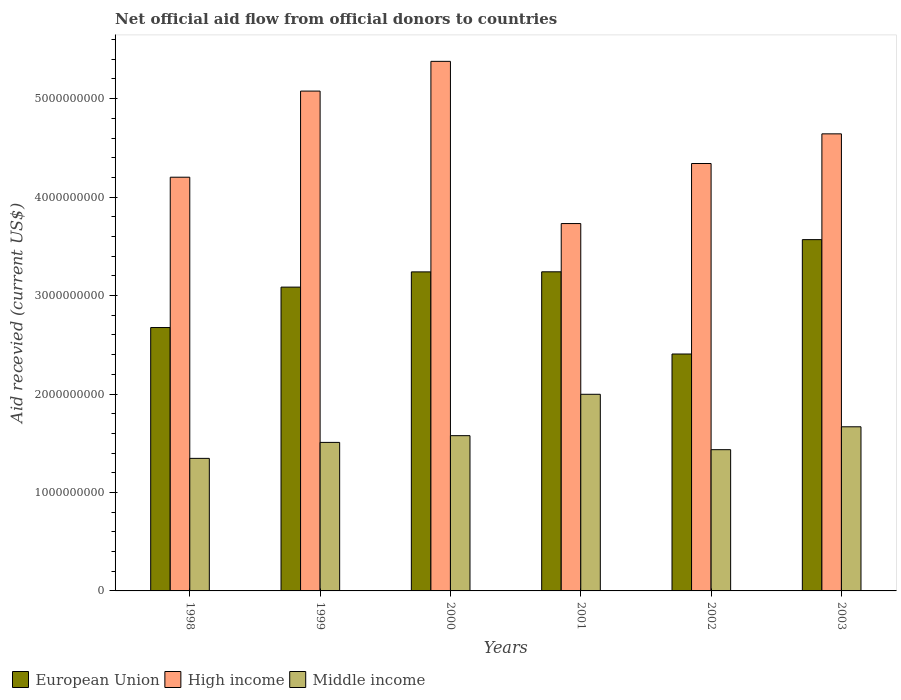How many different coloured bars are there?
Ensure brevity in your answer.  3. Are the number of bars on each tick of the X-axis equal?
Ensure brevity in your answer.  Yes. How many bars are there on the 3rd tick from the right?
Offer a very short reply. 3. What is the label of the 5th group of bars from the left?
Offer a terse response. 2002. In how many cases, is the number of bars for a given year not equal to the number of legend labels?
Provide a short and direct response. 0. What is the total aid received in Middle income in 2000?
Make the answer very short. 1.58e+09. Across all years, what is the maximum total aid received in European Union?
Provide a short and direct response. 3.57e+09. Across all years, what is the minimum total aid received in High income?
Make the answer very short. 3.73e+09. In which year was the total aid received in Middle income maximum?
Your response must be concise. 2001. In which year was the total aid received in European Union minimum?
Your answer should be very brief. 2002. What is the total total aid received in European Union in the graph?
Give a very brief answer. 1.82e+1. What is the difference between the total aid received in Middle income in 2001 and that in 2003?
Keep it short and to the point. 3.30e+08. What is the difference between the total aid received in European Union in 2000 and the total aid received in High income in 2001?
Provide a succinct answer. -4.91e+08. What is the average total aid received in European Union per year?
Ensure brevity in your answer.  3.04e+09. In the year 2000, what is the difference between the total aid received in European Union and total aid received in High income?
Provide a succinct answer. -2.14e+09. What is the ratio of the total aid received in High income in 2000 to that in 2002?
Make the answer very short. 1.24. What is the difference between the highest and the second highest total aid received in Middle income?
Keep it short and to the point. 3.30e+08. What is the difference between the highest and the lowest total aid received in Middle income?
Your answer should be very brief. 6.51e+08. In how many years, is the total aid received in European Union greater than the average total aid received in European Union taken over all years?
Keep it short and to the point. 4. Is the sum of the total aid received in High income in 1999 and 2003 greater than the maximum total aid received in Middle income across all years?
Your response must be concise. Yes. What does the 2nd bar from the right in 1999 represents?
Make the answer very short. High income. Is it the case that in every year, the sum of the total aid received in European Union and total aid received in High income is greater than the total aid received in Middle income?
Ensure brevity in your answer.  Yes. How many bars are there?
Give a very brief answer. 18. Does the graph contain any zero values?
Offer a very short reply. No. Does the graph contain grids?
Provide a succinct answer. No. How many legend labels are there?
Provide a short and direct response. 3. How are the legend labels stacked?
Offer a very short reply. Horizontal. What is the title of the graph?
Provide a short and direct response. Net official aid flow from official donors to countries. Does "Caribbean small states" appear as one of the legend labels in the graph?
Your response must be concise. No. What is the label or title of the Y-axis?
Give a very brief answer. Aid recevied (current US$). What is the Aid recevied (current US$) of European Union in 1998?
Give a very brief answer. 2.68e+09. What is the Aid recevied (current US$) in High income in 1998?
Ensure brevity in your answer.  4.20e+09. What is the Aid recevied (current US$) of Middle income in 1998?
Offer a very short reply. 1.35e+09. What is the Aid recevied (current US$) in European Union in 1999?
Make the answer very short. 3.09e+09. What is the Aid recevied (current US$) in High income in 1999?
Offer a very short reply. 5.08e+09. What is the Aid recevied (current US$) in Middle income in 1999?
Make the answer very short. 1.51e+09. What is the Aid recevied (current US$) in European Union in 2000?
Your response must be concise. 3.24e+09. What is the Aid recevied (current US$) of High income in 2000?
Give a very brief answer. 5.38e+09. What is the Aid recevied (current US$) in Middle income in 2000?
Offer a terse response. 1.58e+09. What is the Aid recevied (current US$) of European Union in 2001?
Your answer should be very brief. 3.24e+09. What is the Aid recevied (current US$) in High income in 2001?
Keep it short and to the point. 3.73e+09. What is the Aid recevied (current US$) in Middle income in 2001?
Provide a short and direct response. 2.00e+09. What is the Aid recevied (current US$) in European Union in 2002?
Offer a terse response. 2.41e+09. What is the Aid recevied (current US$) in High income in 2002?
Offer a terse response. 4.34e+09. What is the Aid recevied (current US$) in Middle income in 2002?
Your answer should be very brief. 1.43e+09. What is the Aid recevied (current US$) in European Union in 2003?
Offer a very short reply. 3.57e+09. What is the Aid recevied (current US$) in High income in 2003?
Keep it short and to the point. 4.64e+09. What is the Aid recevied (current US$) of Middle income in 2003?
Provide a short and direct response. 1.67e+09. Across all years, what is the maximum Aid recevied (current US$) in European Union?
Make the answer very short. 3.57e+09. Across all years, what is the maximum Aid recevied (current US$) of High income?
Provide a succinct answer. 5.38e+09. Across all years, what is the maximum Aid recevied (current US$) of Middle income?
Give a very brief answer. 2.00e+09. Across all years, what is the minimum Aid recevied (current US$) in European Union?
Provide a short and direct response. 2.41e+09. Across all years, what is the minimum Aid recevied (current US$) of High income?
Your answer should be very brief. 3.73e+09. Across all years, what is the minimum Aid recevied (current US$) in Middle income?
Give a very brief answer. 1.35e+09. What is the total Aid recevied (current US$) in European Union in the graph?
Keep it short and to the point. 1.82e+1. What is the total Aid recevied (current US$) in High income in the graph?
Ensure brevity in your answer.  2.74e+1. What is the total Aid recevied (current US$) of Middle income in the graph?
Give a very brief answer. 9.53e+09. What is the difference between the Aid recevied (current US$) of European Union in 1998 and that in 1999?
Offer a terse response. -4.11e+08. What is the difference between the Aid recevied (current US$) of High income in 1998 and that in 1999?
Ensure brevity in your answer.  -8.75e+08. What is the difference between the Aid recevied (current US$) of Middle income in 1998 and that in 1999?
Provide a succinct answer. -1.62e+08. What is the difference between the Aid recevied (current US$) in European Union in 1998 and that in 2000?
Offer a very short reply. -5.65e+08. What is the difference between the Aid recevied (current US$) in High income in 1998 and that in 2000?
Provide a succinct answer. -1.18e+09. What is the difference between the Aid recevied (current US$) of Middle income in 1998 and that in 2000?
Keep it short and to the point. -2.31e+08. What is the difference between the Aid recevied (current US$) of European Union in 1998 and that in 2001?
Keep it short and to the point. -5.66e+08. What is the difference between the Aid recevied (current US$) of High income in 1998 and that in 2001?
Your answer should be compact. 4.71e+08. What is the difference between the Aid recevied (current US$) in Middle income in 1998 and that in 2001?
Give a very brief answer. -6.51e+08. What is the difference between the Aid recevied (current US$) of European Union in 1998 and that in 2002?
Your answer should be compact. 2.69e+08. What is the difference between the Aid recevied (current US$) in High income in 1998 and that in 2002?
Offer a terse response. -1.39e+08. What is the difference between the Aid recevied (current US$) of Middle income in 1998 and that in 2002?
Offer a terse response. -8.82e+07. What is the difference between the Aid recevied (current US$) in European Union in 1998 and that in 2003?
Ensure brevity in your answer.  -8.93e+08. What is the difference between the Aid recevied (current US$) in High income in 1998 and that in 2003?
Keep it short and to the point. -4.40e+08. What is the difference between the Aid recevied (current US$) of Middle income in 1998 and that in 2003?
Your answer should be compact. -3.21e+08. What is the difference between the Aid recevied (current US$) in European Union in 1999 and that in 2000?
Your answer should be very brief. -1.55e+08. What is the difference between the Aid recevied (current US$) of High income in 1999 and that in 2000?
Give a very brief answer. -3.02e+08. What is the difference between the Aid recevied (current US$) in Middle income in 1999 and that in 2000?
Offer a terse response. -6.85e+07. What is the difference between the Aid recevied (current US$) of European Union in 1999 and that in 2001?
Keep it short and to the point. -1.55e+08. What is the difference between the Aid recevied (current US$) of High income in 1999 and that in 2001?
Your answer should be very brief. 1.35e+09. What is the difference between the Aid recevied (current US$) of Middle income in 1999 and that in 2001?
Your answer should be very brief. -4.89e+08. What is the difference between the Aid recevied (current US$) of European Union in 1999 and that in 2002?
Provide a short and direct response. 6.79e+08. What is the difference between the Aid recevied (current US$) of High income in 1999 and that in 2002?
Provide a short and direct response. 7.36e+08. What is the difference between the Aid recevied (current US$) in Middle income in 1999 and that in 2002?
Your response must be concise. 7.39e+07. What is the difference between the Aid recevied (current US$) in European Union in 1999 and that in 2003?
Offer a terse response. -4.82e+08. What is the difference between the Aid recevied (current US$) in High income in 1999 and that in 2003?
Your response must be concise. 4.34e+08. What is the difference between the Aid recevied (current US$) of Middle income in 1999 and that in 2003?
Your answer should be compact. -1.59e+08. What is the difference between the Aid recevied (current US$) in European Union in 2000 and that in 2001?
Offer a very short reply. -7.70e+05. What is the difference between the Aid recevied (current US$) of High income in 2000 and that in 2001?
Give a very brief answer. 1.65e+09. What is the difference between the Aid recevied (current US$) in Middle income in 2000 and that in 2001?
Ensure brevity in your answer.  -4.20e+08. What is the difference between the Aid recevied (current US$) in European Union in 2000 and that in 2002?
Ensure brevity in your answer.  8.34e+08. What is the difference between the Aid recevied (current US$) in High income in 2000 and that in 2002?
Offer a very short reply. 1.04e+09. What is the difference between the Aid recevied (current US$) of Middle income in 2000 and that in 2002?
Ensure brevity in your answer.  1.42e+08. What is the difference between the Aid recevied (current US$) in European Union in 2000 and that in 2003?
Your answer should be compact. -3.28e+08. What is the difference between the Aid recevied (current US$) in High income in 2000 and that in 2003?
Offer a terse response. 7.36e+08. What is the difference between the Aid recevied (current US$) in Middle income in 2000 and that in 2003?
Your response must be concise. -9.02e+07. What is the difference between the Aid recevied (current US$) of European Union in 2001 and that in 2002?
Keep it short and to the point. 8.35e+08. What is the difference between the Aid recevied (current US$) of High income in 2001 and that in 2002?
Provide a short and direct response. -6.10e+08. What is the difference between the Aid recevied (current US$) in Middle income in 2001 and that in 2002?
Give a very brief answer. 5.63e+08. What is the difference between the Aid recevied (current US$) of European Union in 2001 and that in 2003?
Keep it short and to the point. -3.27e+08. What is the difference between the Aid recevied (current US$) in High income in 2001 and that in 2003?
Your answer should be very brief. -9.11e+08. What is the difference between the Aid recevied (current US$) of Middle income in 2001 and that in 2003?
Your answer should be very brief. 3.30e+08. What is the difference between the Aid recevied (current US$) of European Union in 2002 and that in 2003?
Your response must be concise. -1.16e+09. What is the difference between the Aid recevied (current US$) of High income in 2002 and that in 2003?
Make the answer very short. -3.01e+08. What is the difference between the Aid recevied (current US$) of Middle income in 2002 and that in 2003?
Provide a short and direct response. -2.33e+08. What is the difference between the Aid recevied (current US$) of European Union in 1998 and the Aid recevied (current US$) of High income in 1999?
Your answer should be compact. -2.40e+09. What is the difference between the Aid recevied (current US$) of European Union in 1998 and the Aid recevied (current US$) of Middle income in 1999?
Give a very brief answer. 1.17e+09. What is the difference between the Aid recevied (current US$) of High income in 1998 and the Aid recevied (current US$) of Middle income in 1999?
Your answer should be compact. 2.69e+09. What is the difference between the Aid recevied (current US$) of European Union in 1998 and the Aid recevied (current US$) of High income in 2000?
Ensure brevity in your answer.  -2.70e+09. What is the difference between the Aid recevied (current US$) of European Union in 1998 and the Aid recevied (current US$) of Middle income in 2000?
Your answer should be compact. 1.10e+09. What is the difference between the Aid recevied (current US$) of High income in 1998 and the Aid recevied (current US$) of Middle income in 2000?
Give a very brief answer. 2.63e+09. What is the difference between the Aid recevied (current US$) of European Union in 1998 and the Aid recevied (current US$) of High income in 2001?
Offer a terse response. -1.06e+09. What is the difference between the Aid recevied (current US$) in European Union in 1998 and the Aid recevied (current US$) in Middle income in 2001?
Give a very brief answer. 6.78e+08. What is the difference between the Aid recevied (current US$) in High income in 1998 and the Aid recevied (current US$) in Middle income in 2001?
Offer a terse response. 2.20e+09. What is the difference between the Aid recevied (current US$) in European Union in 1998 and the Aid recevied (current US$) in High income in 2002?
Offer a very short reply. -1.67e+09. What is the difference between the Aid recevied (current US$) in European Union in 1998 and the Aid recevied (current US$) in Middle income in 2002?
Your response must be concise. 1.24e+09. What is the difference between the Aid recevied (current US$) of High income in 1998 and the Aid recevied (current US$) of Middle income in 2002?
Keep it short and to the point. 2.77e+09. What is the difference between the Aid recevied (current US$) of European Union in 1998 and the Aid recevied (current US$) of High income in 2003?
Your response must be concise. -1.97e+09. What is the difference between the Aid recevied (current US$) in European Union in 1998 and the Aid recevied (current US$) in Middle income in 2003?
Provide a succinct answer. 1.01e+09. What is the difference between the Aid recevied (current US$) of High income in 1998 and the Aid recevied (current US$) of Middle income in 2003?
Your answer should be compact. 2.53e+09. What is the difference between the Aid recevied (current US$) in European Union in 1999 and the Aid recevied (current US$) in High income in 2000?
Your answer should be very brief. -2.29e+09. What is the difference between the Aid recevied (current US$) in European Union in 1999 and the Aid recevied (current US$) in Middle income in 2000?
Offer a terse response. 1.51e+09. What is the difference between the Aid recevied (current US$) of High income in 1999 and the Aid recevied (current US$) of Middle income in 2000?
Your response must be concise. 3.50e+09. What is the difference between the Aid recevied (current US$) in European Union in 1999 and the Aid recevied (current US$) in High income in 2001?
Provide a short and direct response. -6.46e+08. What is the difference between the Aid recevied (current US$) in European Union in 1999 and the Aid recevied (current US$) in Middle income in 2001?
Ensure brevity in your answer.  1.09e+09. What is the difference between the Aid recevied (current US$) in High income in 1999 and the Aid recevied (current US$) in Middle income in 2001?
Ensure brevity in your answer.  3.08e+09. What is the difference between the Aid recevied (current US$) of European Union in 1999 and the Aid recevied (current US$) of High income in 2002?
Offer a very short reply. -1.26e+09. What is the difference between the Aid recevied (current US$) of European Union in 1999 and the Aid recevied (current US$) of Middle income in 2002?
Your response must be concise. 1.65e+09. What is the difference between the Aid recevied (current US$) in High income in 1999 and the Aid recevied (current US$) in Middle income in 2002?
Your answer should be compact. 3.64e+09. What is the difference between the Aid recevied (current US$) of European Union in 1999 and the Aid recevied (current US$) of High income in 2003?
Provide a short and direct response. -1.56e+09. What is the difference between the Aid recevied (current US$) in European Union in 1999 and the Aid recevied (current US$) in Middle income in 2003?
Your response must be concise. 1.42e+09. What is the difference between the Aid recevied (current US$) of High income in 1999 and the Aid recevied (current US$) of Middle income in 2003?
Your answer should be compact. 3.41e+09. What is the difference between the Aid recevied (current US$) of European Union in 2000 and the Aid recevied (current US$) of High income in 2001?
Ensure brevity in your answer.  -4.91e+08. What is the difference between the Aid recevied (current US$) of European Union in 2000 and the Aid recevied (current US$) of Middle income in 2001?
Your answer should be compact. 1.24e+09. What is the difference between the Aid recevied (current US$) of High income in 2000 and the Aid recevied (current US$) of Middle income in 2001?
Your response must be concise. 3.38e+09. What is the difference between the Aid recevied (current US$) in European Union in 2000 and the Aid recevied (current US$) in High income in 2002?
Keep it short and to the point. -1.10e+09. What is the difference between the Aid recevied (current US$) in European Union in 2000 and the Aid recevied (current US$) in Middle income in 2002?
Offer a terse response. 1.81e+09. What is the difference between the Aid recevied (current US$) of High income in 2000 and the Aid recevied (current US$) of Middle income in 2002?
Make the answer very short. 3.94e+09. What is the difference between the Aid recevied (current US$) of European Union in 2000 and the Aid recevied (current US$) of High income in 2003?
Ensure brevity in your answer.  -1.40e+09. What is the difference between the Aid recevied (current US$) of European Union in 2000 and the Aid recevied (current US$) of Middle income in 2003?
Your answer should be very brief. 1.57e+09. What is the difference between the Aid recevied (current US$) in High income in 2000 and the Aid recevied (current US$) in Middle income in 2003?
Provide a short and direct response. 3.71e+09. What is the difference between the Aid recevied (current US$) of European Union in 2001 and the Aid recevied (current US$) of High income in 2002?
Provide a succinct answer. -1.10e+09. What is the difference between the Aid recevied (current US$) of European Union in 2001 and the Aid recevied (current US$) of Middle income in 2002?
Provide a short and direct response. 1.81e+09. What is the difference between the Aid recevied (current US$) in High income in 2001 and the Aid recevied (current US$) in Middle income in 2002?
Provide a short and direct response. 2.30e+09. What is the difference between the Aid recevied (current US$) in European Union in 2001 and the Aid recevied (current US$) in High income in 2003?
Your answer should be compact. -1.40e+09. What is the difference between the Aid recevied (current US$) in European Union in 2001 and the Aid recevied (current US$) in Middle income in 2003?
Offer a very short reply. 1.57e+09. What is the difference between the Aid recevied (current US$) of High income in 2001 and the Aid recevied (current US$) of Middle income in 2003?
Keep it short and to the point. 2.06e+09. What is the difference between the Aid recevied (current US$) of European Union in 2002 and the Aid recevied (current US$) of High income in 2003?
Provide a succinct answer. -2.24e+09. What is the difference between the Aid recevied (current US$) in European Union in 2002 and the Aid recevied (current US$) in Middle income in 2003?
Your answer should be very brief. 7.39e+08. What is the difference between the Aid recevied (current US$) in High income in 2002 and the Aid recevied (current US$) in Middle income in 2003?
Offer a very short reply. 2.67e+09. What is the average Aid recevied (current US$) in European Union per year?
Provide a short and direct response. 3.04e+09. What is the average Aid recevied (current US$) of High income per year?
Ensure brevity in your answer.  4.56e+09. What is the average Aid recevied (current US$) of Middle income per year?
Your answer should be compact. 1.59e+09. In the year 1998, what is the difference between the Aid recevied (current US$) of European Union and Aid recevied (current US$) of High income?
Your answer should be compact. -1.53e+09. In the year 1998, what is the difference between the Aid recevied (current US$) of European Union and Aid recevied (current US$) of Middle income?
Your response must be concise. 1.33e+09. In the year 1998, what is the difference between the Aid recevied (current US$) of High income and Aid recevied (current US$) of Middle income?
Make the answer very short. 2.86e+09. In the year 1999, what is the difference between the Aid recevied (current US$) in European Union and Aid recevied (current US$) in High income?
Offer a terse response. -1.99e+09. In the year 1999, what is the difference between the Aid recevied (current US$) in European Union and Aid recevied (current US$) in Middle income?
Ensure brevity in your answer.  1.58e+09. In the year 1999, what is the difference between the Aid recevied (current US$) of High income and Aid recevied (current US$) of Middle income?
Keep it short and to the point. 3.57e+09. In the year 2000, what is the difference between the Aid recevied (current US$) of European Union and Aid recevied (current US$) of High income?
Ensure brevity in your answer.  -2.14e+09. In the year 2000, what is the difference between the Aid recevied (current US$) in European Union and Aid recevied (current US$) in Middle income?
Your response must be concise. 1.66e+09. In the year 2000, what is the difference between the Aid recevied (current US$) in High income and Aid recevied (current US$) in Middle income?
Ensure brevity in your answer.  3.80e+09. In the year 2001, what is the difference between the Aid recevied (current US$) of European Union and Aid recevied (current US$) of High income?
Ensure brevity in your answer.  -4.90e+08. In the year 2001, what is the difference between the Aid recevied (current US$) of European Union and Aid recevied (current US$) of Middle income?
Give a very brief answer. 1.24e+09. In the year 2001, what is the difference between the Aid recevied (current US$) in High income and Aid recevied (current US$) in Middle income?
Your answer should be compact. 1.73e+09. In the year 2002, what is the difference between the Aid recevied (current US$) in European Union and Aid recevied (current US$) in High income?
Your answer should be very brief. -1.93e+09. In the year 2002, what is the difference between the Aid recevied (current US$) of European Union and Aid recevied (current US$) of Middle income?
Offer a terse response. 9.72e+08. In the year 2002, what is the difference between the Aid recevied (current US$) in High income and Aid recevied (current US$) in Middle income?
Provide a succinct answer. 2.91e+09. In the year 2003, what is the difference between the Aid recevied (current US$) of European Union and Aid recevied (current US$) of High income?
Keep it short and to the point. -1.07e+09. In the year 2003, what is the difference between the Aid recevied (current US$) of European Union and Aid recevied (current US$) of Middle income?
Make the answer very short. 1.90e+09. In the year 2003, what is the difference between the Aid recevied (current US$) of High income and Aid recevied (current US$) of Middle income?
Offer a terse response. 2.98e+09. What is the ratio of the Aid recevied (current US$) of European Union in 1998 to that in 1999?
Give a very brief answer. 0.87. What is the ratio of the Aid recevied (current US$) of High income in 1998 to that in 1999?
Offer a terse response. 0.83. What is the ratio of the Aid recevied (current US$) of Middle income in 1998 to that in 1999?
Give a very brief answer. 0.89. What is the ratio of the Aid recevied (current US$) in European Union in 1998 to that in 2000?
Give a very brief answer. 0.83. What is the ratio of the Aid recevied (current US$) in High income in 1998 to that in 2000?
Provide a short and direct response. 0.78. What is the ratio of the Aid recevied (current US$) of Middle income in 1998 to that in 2000?
Your answer should be compact. 0.85. What is the ratio of the Aid recevied (current US$) in European Union in 1998 to that in 2001?
Give a very brief answer. 0.83. What is the ratio of the Aid recevied (current US$) of High income in 1998 to that in 2001?
Make the answer very short. 1.13. What is the ratio of the Aid recevied (current US$) of Middle income in 1998 to that in 2001?
Offer a terse response. 0.67. What is the ratio of the Aid recevied (current US$) in European Union in 1998 to that in 2002?
Provide a short and direct response. 1.11. What is the ratio of the Aid recevied (current US$) of Middle income in 1998 to that in 2002?
Offer a very short reply. 0.94. What is the ratio of the Aid recevied (current US$) in European Union in 1998 to that in 2003?
Give a very brief answer. 0.75. What is the ratio of the Aid recevied (current US$) in High income in 1998 to that in 2003?
Keep it short and to the point. 0.91. What is the ratio of the Aid recevied (current US$) of Middle income in 1998 to that in 2003?
Keep it short and to the point. 0.81. What is the ratio of the Aid recevied (current US$) of European Union in 1999 to that in 2000?
Ensure brevity in your answer.  0.95. What is the ratio of the Aid recevied (current US$) in High income in 1999 to that in 2000?
Make the answer very short. 0.94. What is the ratio of the Aid recevied (current US$) of Middle income in 1999 to that in 2000?
Offer a terse response. 0.96. What is the ratio of the Aid recevied (current US$) in European Union in 1999 to that in 2001?
Your answer should be compact. 0.95. What is the ratio of the Aid recevied (current US$) in High income in 1999 to that in 2001?
Your answer should be compact. 1.36. What is the ratio of the Aid recevied (current US$) in Middle income in 1999 to that in 2001?
Provide a succinct answer. 0.76. What is the ratio of the Aid recevied (current US$) of European Union in 1999 to that in 2002?
Keep it short and to the point. 1.28. What is the ratio of the Aid recevied (current US$) in High income in 1999 to that in 2002?
Your answer should be compact. 1.17. What is the ratio of the Aid recevied (current US$) of Middle income in 1999 to that in 2002?
Your answer should be compact. 1.05. What is the ratio of the Aid recevied (current US$) in European Union in 1999 to that in 2003?
Make the answer very short. 0.86. What is the ratio of the Aid recevied (current US$) of High income in 1999 to that in 2003?
Give a very brief answer. 1.09. What is the ratio of the Aid recevied (current US$) of Middle income in 1999 to that in 2003?
Provide a short and direct response. 0.9. What is the ratio of the Aid recevied (current US$) in European Union in 2000 to that in 2001?
Your response must be concise. 1. What is the ratio of the Aid recevied (current US$) of High income in 2000 to that in 2001?
Make the answer very short. 1.44. What is the ratio of the Aid recevied (current US$) in Middle income in 2000 to that in 2001?
Offer a terse response. 0.79. What is the ratio of the Aid recevied (current US$) in European Union in 2000 to that in 2002?
Provide a succinct answer. 1.35. What is the ratio of the Aid recevied (current US$) in High income in 2000 to that in 2002?
Your response must be concise. 1.24. What is the ratio of the Aid recevied (current US$) of Middle income in 2000 to that in 2002?
Give a very brief answer. 1.1. What is the ratio of the Aid recevied (current US$) of European Union in 2000 to that in 2003?
Your answer should be compact. 0.91. What is the ratio of the Aid recevied (current US$) in High income in 2000 to that in 2003?
Offer a very short reply. 1.16. What is the ratio of the Aid recevied (current US$) in Middle income in 2000 to that in 2003?
Give a very brief answer. 0.95. What is the ratio of the Aid recevied (current US$) of European Union in 2001 to that in 2002?
Make the answer very short. 1.35. What is the ratio of the Aid recevied (current US$) of High income in 2001 to that in 2002?
Give a very brief answer. 0.86. What is the ratio of the Aid recevied (current US$) of Middle income in 2001 to that in 2002?
Provide a succinct answer. 1.39. What is the ratio of the Aid recevied (current US$) of European Union in 2001 to that in 2003?
Offer a terse response. 0.91. What is the ratio of the Aid recevied (current US$) of High income in 2001 to that in 2003?
Give a very brief answer. 0.8. What is the ratio of the Aid recevied (current US$) in Middle income in 2001 to that in 2003?
Offer a very short reply. 1.2. What is the ratio of the Aid recevied (current US$) of European Union in 2002 to that in 2003?
Offer a terse response. 0.67. What is the ratio of the Aid recevied (current US$) of High income in 2002 to that in 2003?
Ensure brevity in your answer.  0.94. What is the ratio of the Aid recevied (current US$) of Middle income in 2002 to that in 2003?
Keep it short and to the point. 0.86. What is the difference between the highest and the second highest Aid recevied (current US$) in European Union?
Offer a terse response. 3.27e+08. What is the difference between the highest and the second highest Aid recevied (current US$) of High income?
Make the answer very short. 3.02e+08. What is the difference between the highest and the second highest Aid recevied (current US$) of Middle income?
Your answer should be very brief. 3.30e+08. What is the difference between the highest and the lowest Aid recevied (current US$) in European Union?
Offer a very short reply. 1.16e+09. What is the difference between the highest and the lowest Aid recevied (current US$) of High income?
Offer a terse response. 1.65e+09. What is the difference between the highest and the lowest Aid recevied (current US$) of Middle income?
Your answer should be very brief. 6.51e+08. 